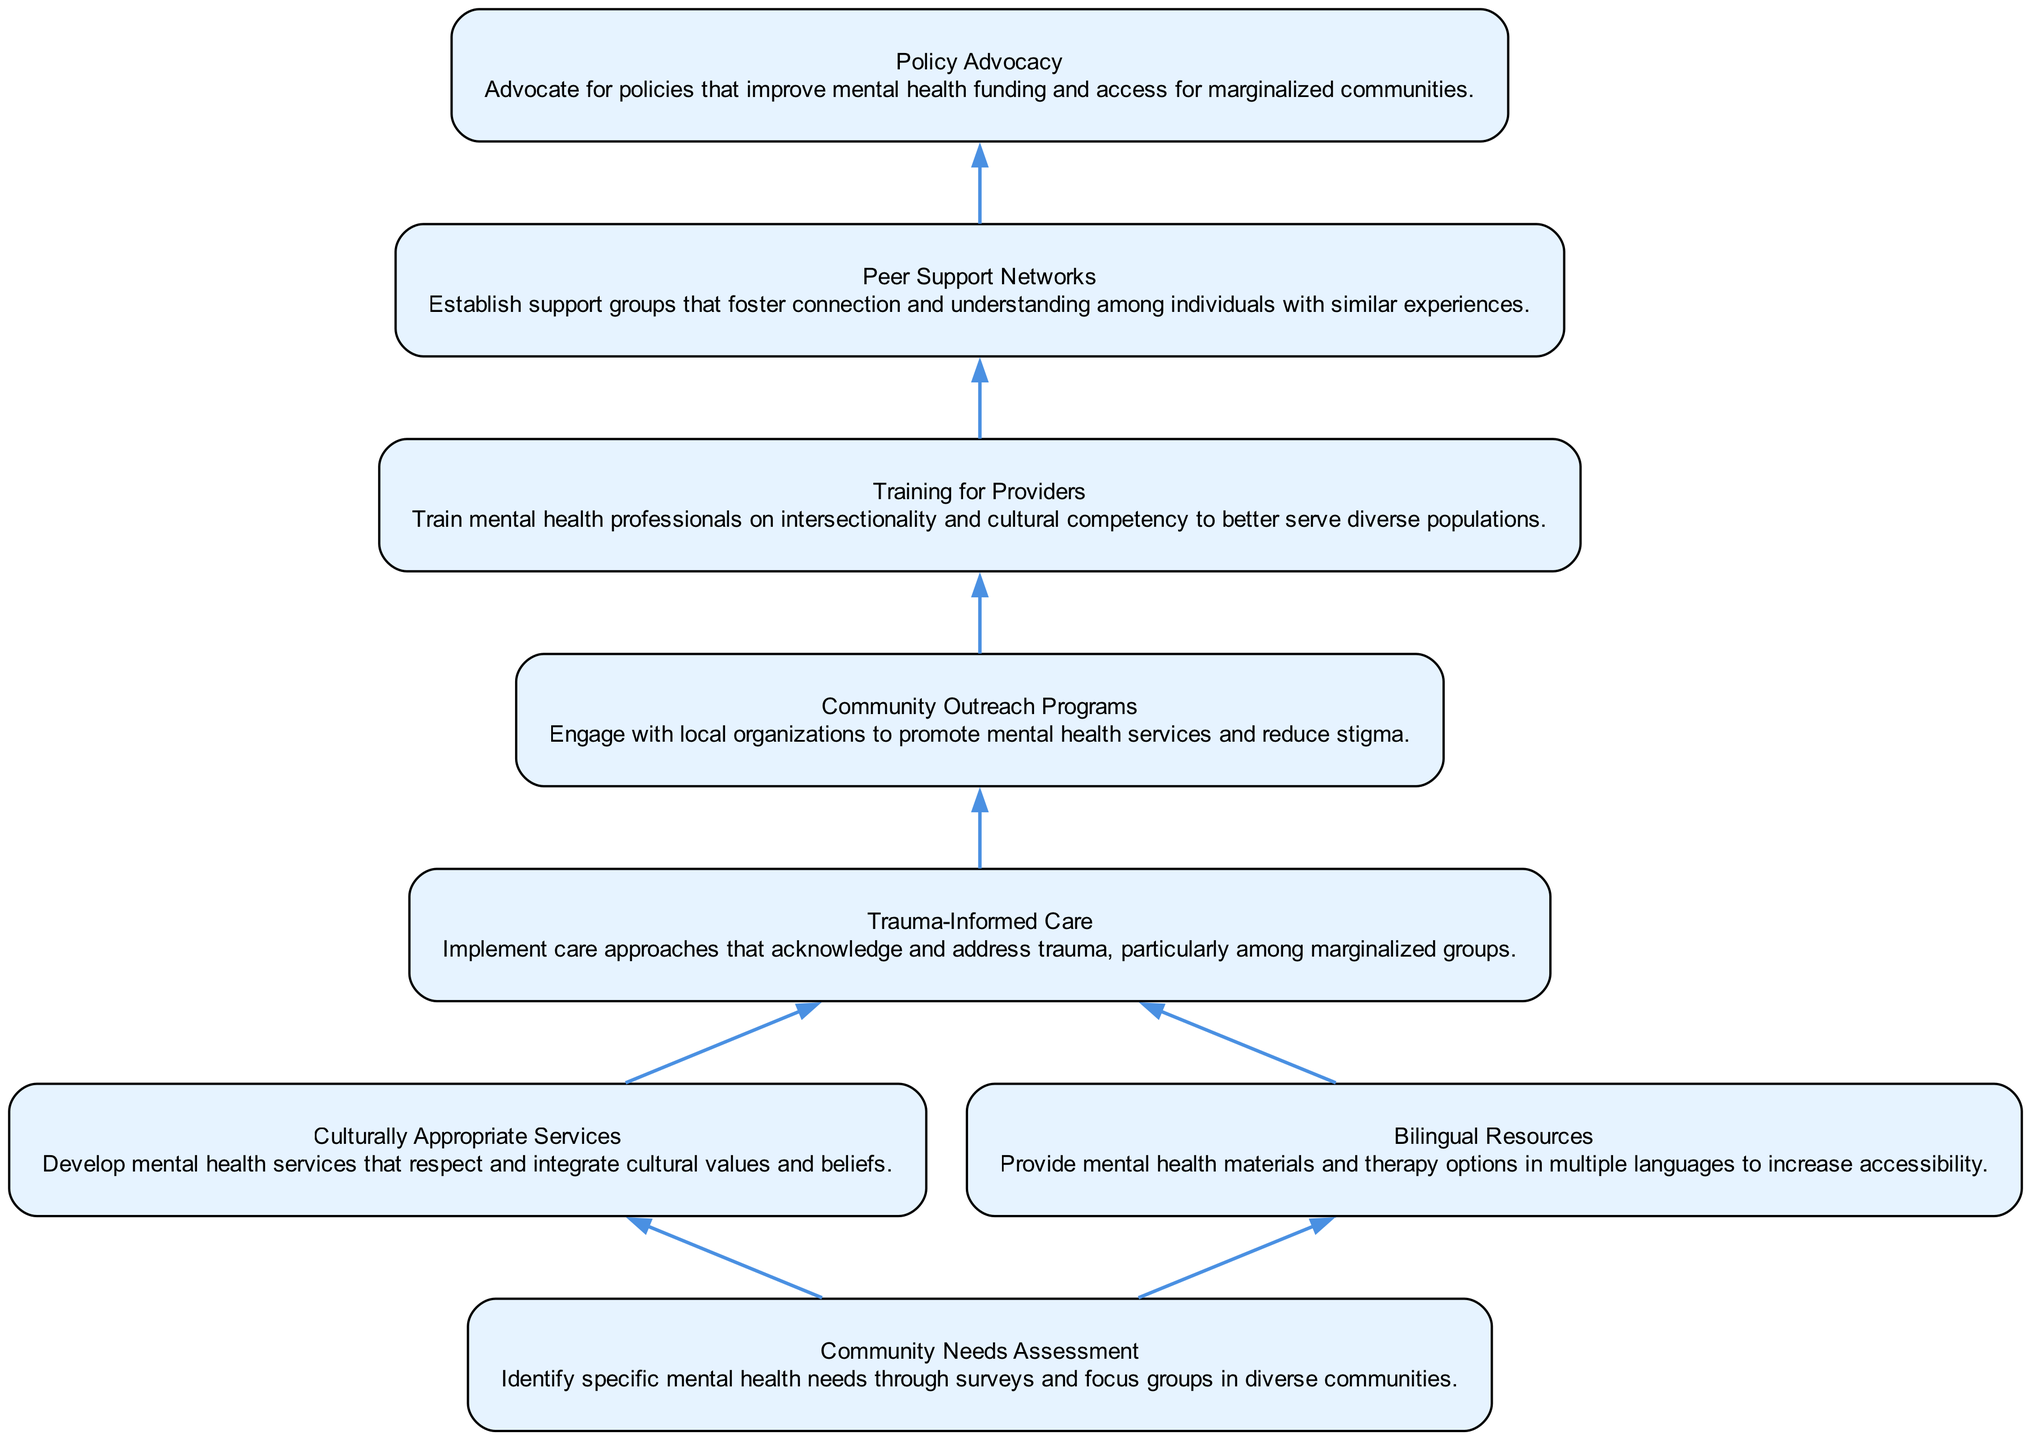What is the first node in the diagram? The first node in the diagram is labeled "Community Needs Assessment," which is the starting point of the flow chart.
Answer: Community Needs Assessment How many total nodes are in the diagram? By counting each distinct element represented in the diagram, there are a total of eight nodes.
Answer: 8 Which node connects to 'Trauma-Informed Care'? The nodes that connect to 'Trauma-Informed Care' are 'Culturally Appropriate Services' and 'Bilingual Resources', both leading into 'Trauma-Informed Care'.
Answer: Culturally Appropriate Services, Bilingual Resources What is the last node in the flow chart? The last node in the flow chart is 'Policy Advocacy', which concludes the bottom-up flow of the various mental health service elements.
Answer: Policy Advocacy What is the primary function of 'Community Outreach Programs'? The description indicates that 'Community Outreach Programs' engage with local organizations to promote mental health services and reduce stigma, thus aiming to improve community awareness and acceptance.
Answer: Engage with local organizations to promote mental health services and reduce stigma How many edges connect to 'Training for Providers'? The 'Training for Providers' node has one incoming edge from 'Community Outreach Programs' and one outgoing edge to 'Peer Support Networks', totaling two edges connected to it.
Answer: 2 What two elements come from 'Culturally Appropriate Services' in the flow? In the flow, 'Culturally Appropriate Services' leads to 'Trauma-Informed Care', which directly follows it.
Answer: Trauma-Informed Care Why is 'Bilingual Resources' important in this flow? 'Bilingual Resources' is critical because it increases accessibility by providing mental health materials and therapy in multiple languages, addressing language barriers in diverse populations.
Answer: Increases accessibility by providing resources in multiple languages 